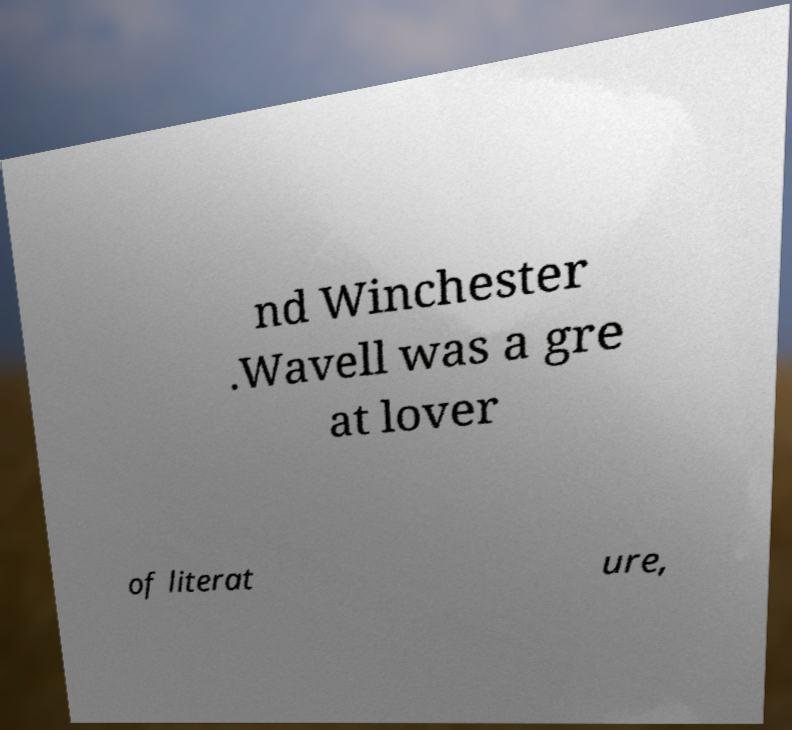There's text embedded in this image that I need extracted. Can you transcribe it verbatim? nd Winchester .Wavell was a gre at lover of literat ure, 